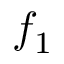<formula> <loc_0><loc_0><loc_500><loc_500>f _ { 1 }</formula> 